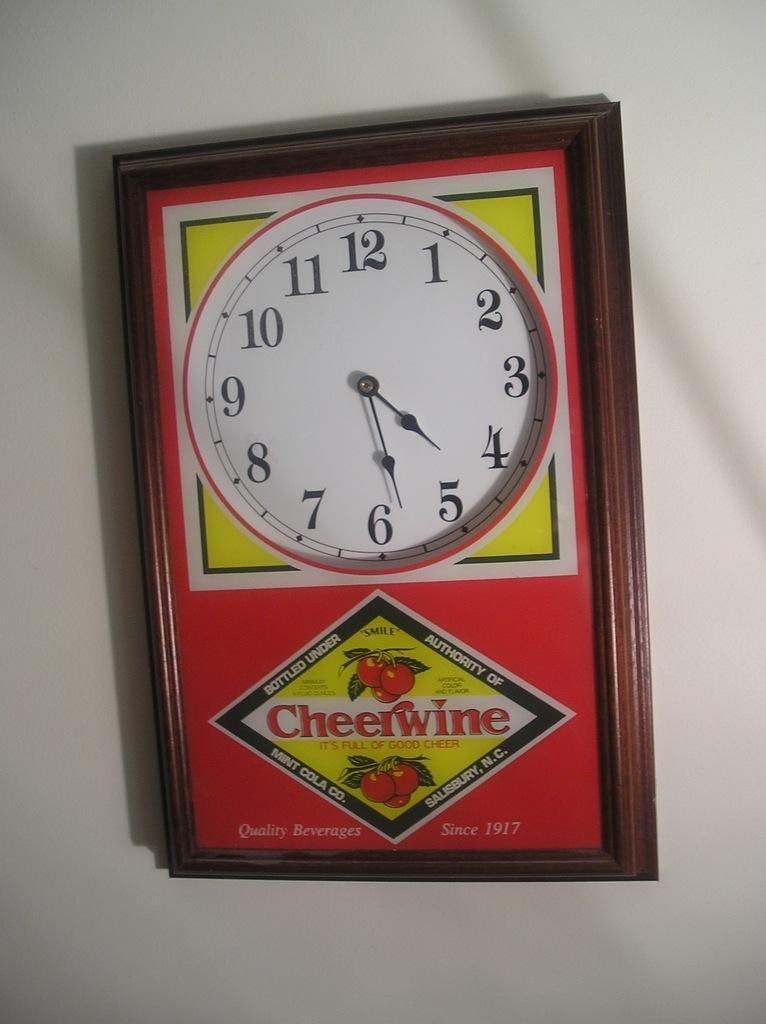<image>
Write a terse but informative summary of the picture. A Cheerwine block that is set to 4:28 